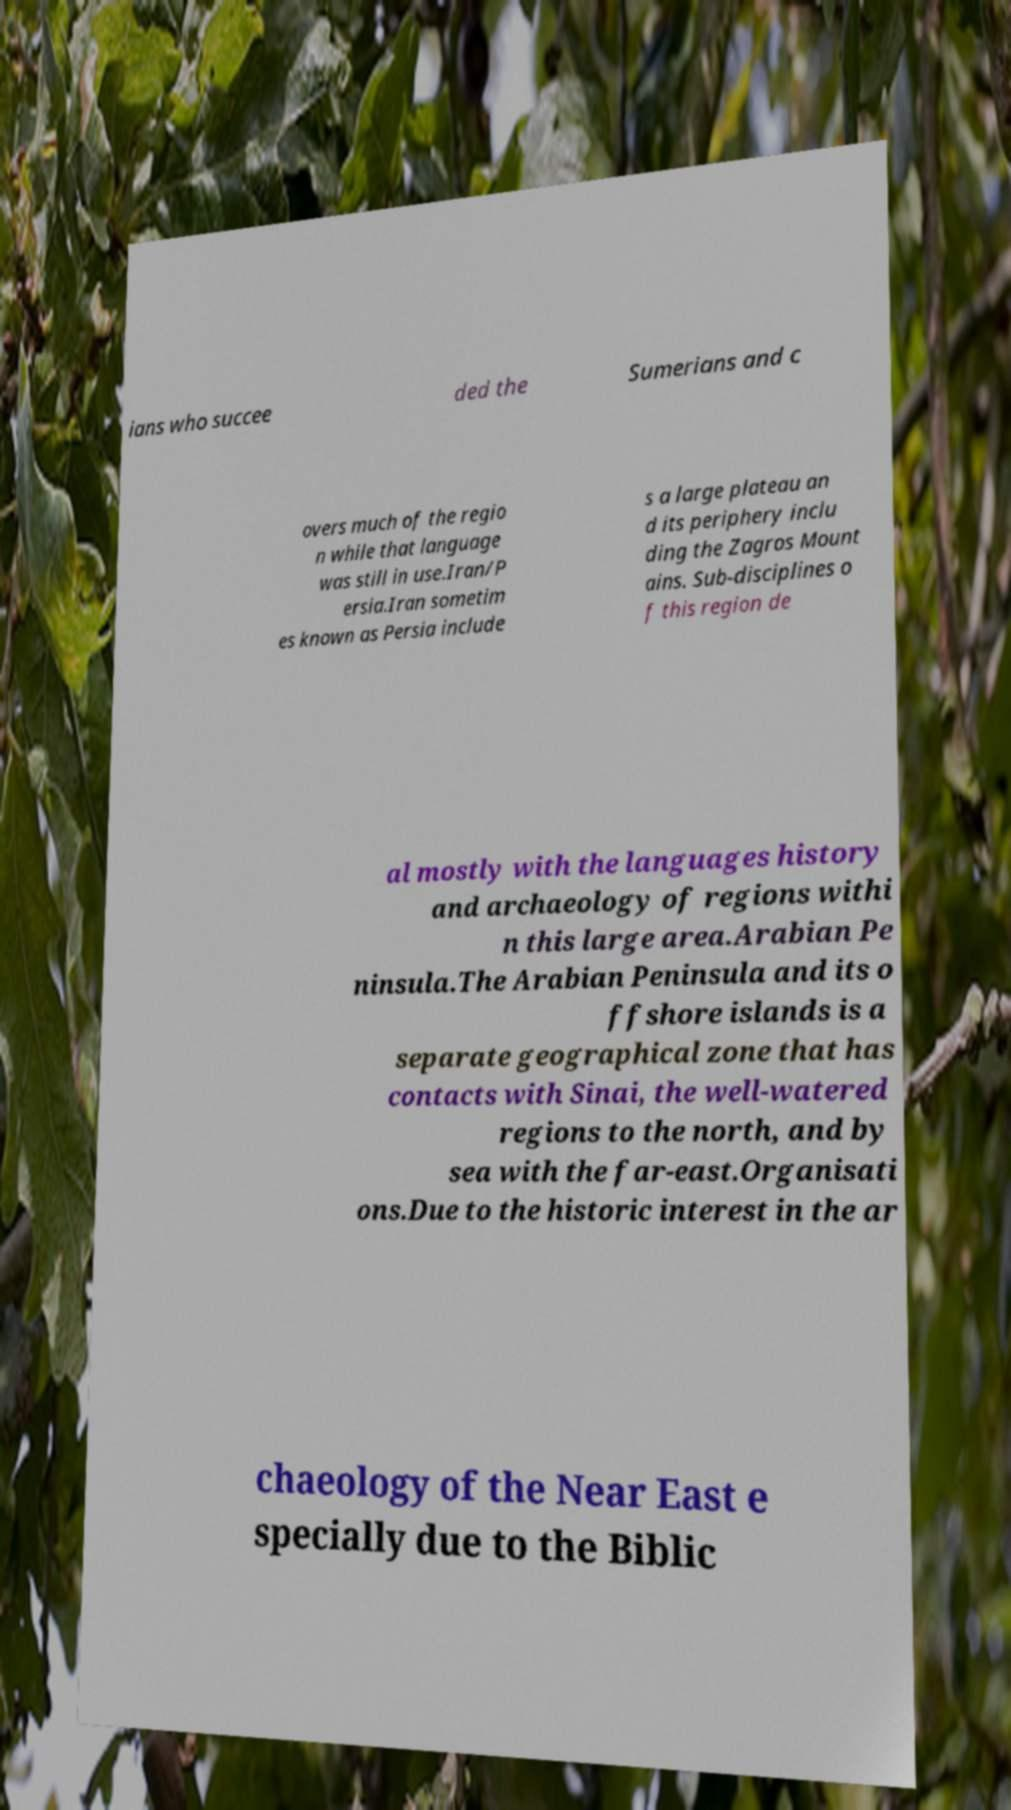Please identify and transcribe the text found in this image. ians who succee ded the Sumerians and c overs much of the regio n while that language was still in use.Iran/P ersia.Iran sometim es known as Persia include s a large plateau an d its periphery inclu ding the Zagros Mount ains. Sub-disciplines o f this region de al mostly with the languages history and archaeology of regions withi n this large area.Arabian Pe ninsula.The Arabian Peninsula and its o ffshore islands is a separate geographical zone that has contacts with Sinai, the well-watered regions to the north, and by sea with the far-east.Organisati ons.Due to the historic interest in the ar chaeology of the Near East e specially due to the Biblic 